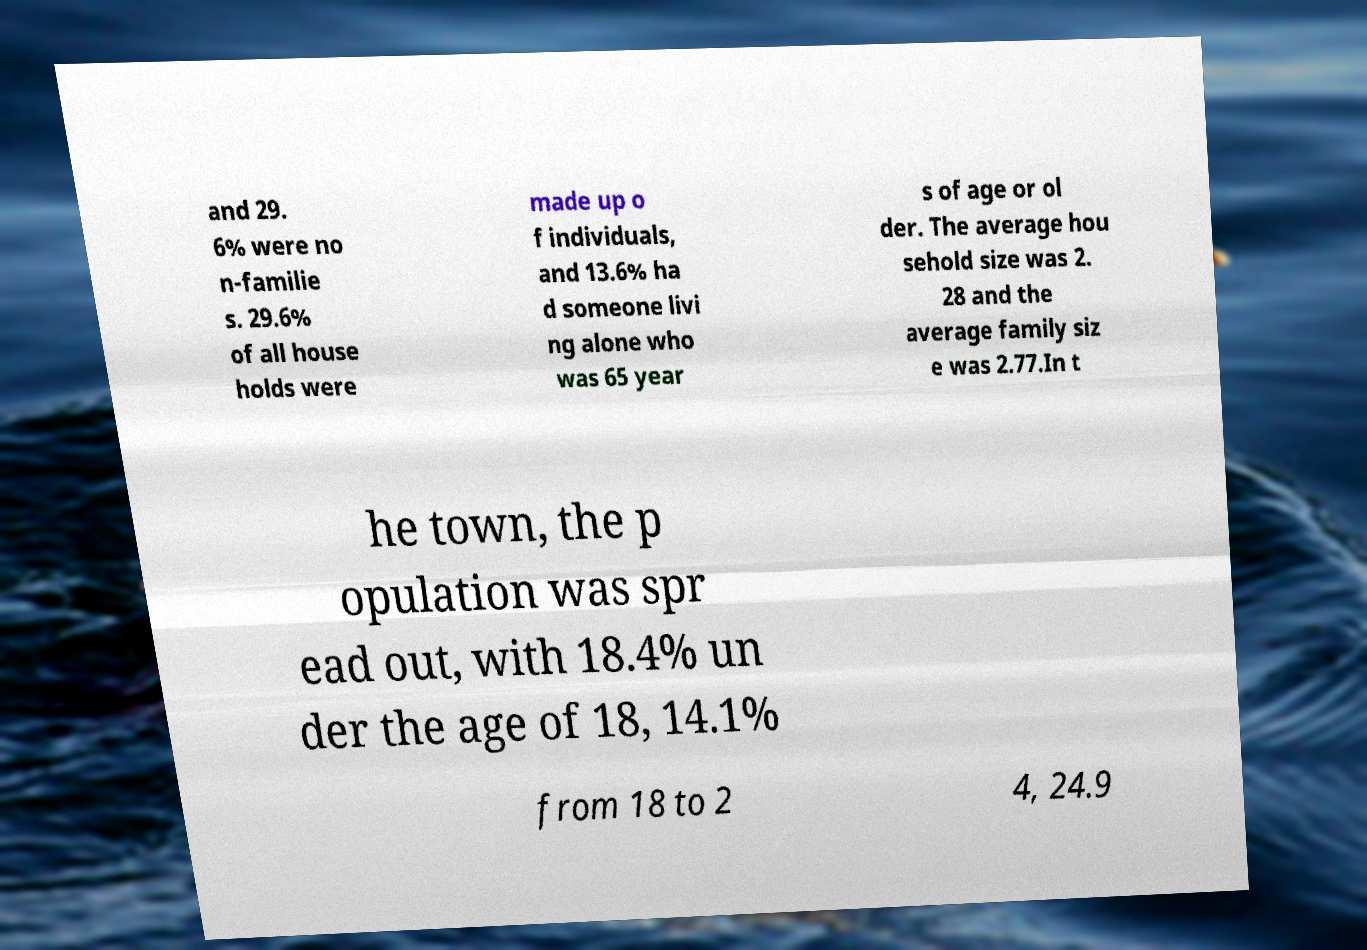For documentation purposes, I need the text within this image transcribed. Could you provide that? and 29. 6% were no n-familie s. 29.6% of all house holds were made up o f individuals, and 13.6% ha d someone livi ng alone who was 65 year s of age or ol der. The average hou sehold size was 2. 28 and the average family siz e was 2.77.In t he town, the p opulation was spr ead out, with 18.4% un der the age of 18, 14.1% from 18 to 2 4, 24.9 